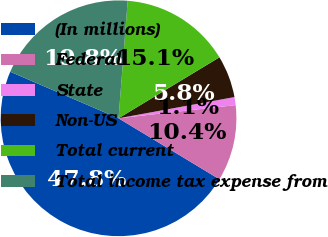<chart> <loc_0><loc_0><loc_500><loc_500><pie_chart><fcel>(In millions)<fcel>Federal<fcel>State<fcel>Non-US<fcel>Total current<fcel>Total income tax expense from<nl><fcel>47.81%<fcel>10.44%<fcel>1.1%<fcel>5.77%<fcel>15.11%<fcel>19.78%<nl></chart> 